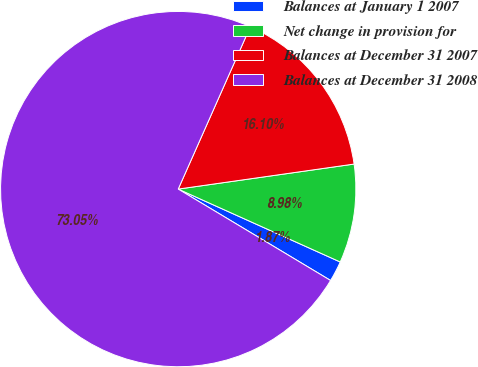Convert chart. <chart><loc_0><loc_0><loc_500><loc_500><pie_chart><fcel>Balances at January 1 2007<fcel>Net change in provision for<fcel>Balances at December 31 2007<fcel>Balances at December 31 2008<nl><fcel>1.87%<fcel>8.98%<fcel>16.1%<fcel>73.05%<nl></chart> 